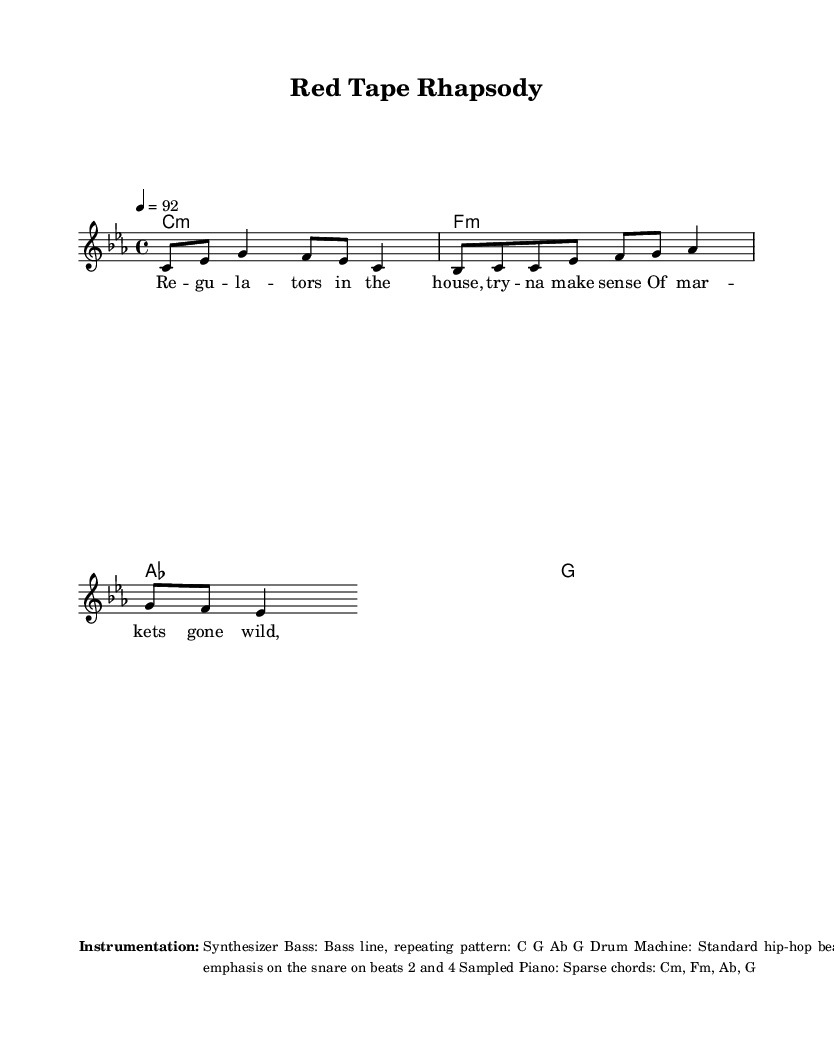What is the key signature of this music? The key signature is C minor, which has three flats: B flat, E flat, and A flat. This can be determined by looking at the clef and identifying the flats in the key signature at the beginning of the staff.
Answer: C minor What is the time signature of the music? The time signature is 4/4, indicated at the beginning of the score. This means there are four beats in each measure, and the quarter note receives one beat.
Answer: 4/4 What is the tempo marking for this piece? The tempo marking is quarter note equals 92 (4=92), which indicates that the piece should be played at a moderate pace of 92 beats per minute. This information is usually found in the tempo section of the score.
Answer: 92 How many verses are in the structure of the piece? The structure of this rap includes two verses, as mentioned in the breakdown of the song structure listed in the score. The verses are typically separated by a chorus, highlighting their importance within the piece.
Answer: Two What instrument is likely emphasized in the accompaniment? The instrument emphasized in the accompaniment is the Synthesizer Bass, as it's mentioned in the instrumentation overview provided with the score. The bass adds depth and rhythmic energy, which is essential in rap music.
Answer: Synthesizer Bass What rhythmic style should the melody be performed in? The melody should be performed in a rhythmic, speech-like manner, which is typical of rap vocal delivery. This instruction indicates how the performer should interpret the rhythmic flow of the lyrics while rapping.
Answer: Rhythmic, speech-like What is the overall mood suggested by the title "Red Tape Rhapsody"? The title suggests a satirical and possibly critical mood towards bureaucracy and the complexities of financial systems. The word "Rhapsody" implies a lyrical flow, while "Red Tape" indicates frustration with bureaucratic obstacles, aligning with the satirical tone of rap.
Answer: Satirical 